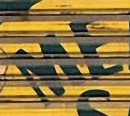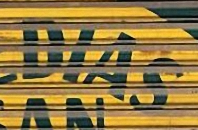Read the text content from these images in order, separated by a semicolon. ME; DIAS 